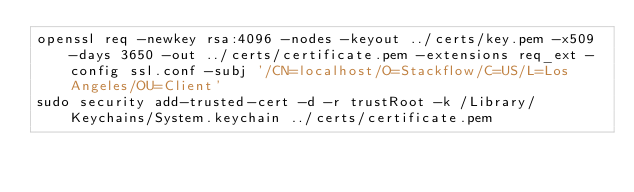<code> <loc_0><loc_0><loc_500><loc_500><_Bash_>openssl req -newkey rsa:4096 -nodes -keyout ../certs/key.pem -x509 -days 3650 -out ../certs/certificate.pem -extensions req_ext -config ssl.conf -subj '/CN=localhost/O=Stackflow/C=US/L=Los Angeles/OU=Client'
sudo security add-trusted-cert -d -r trustRoot -k /Library/Keychains/System.keychain ../certs/certificate.pem
</code> 